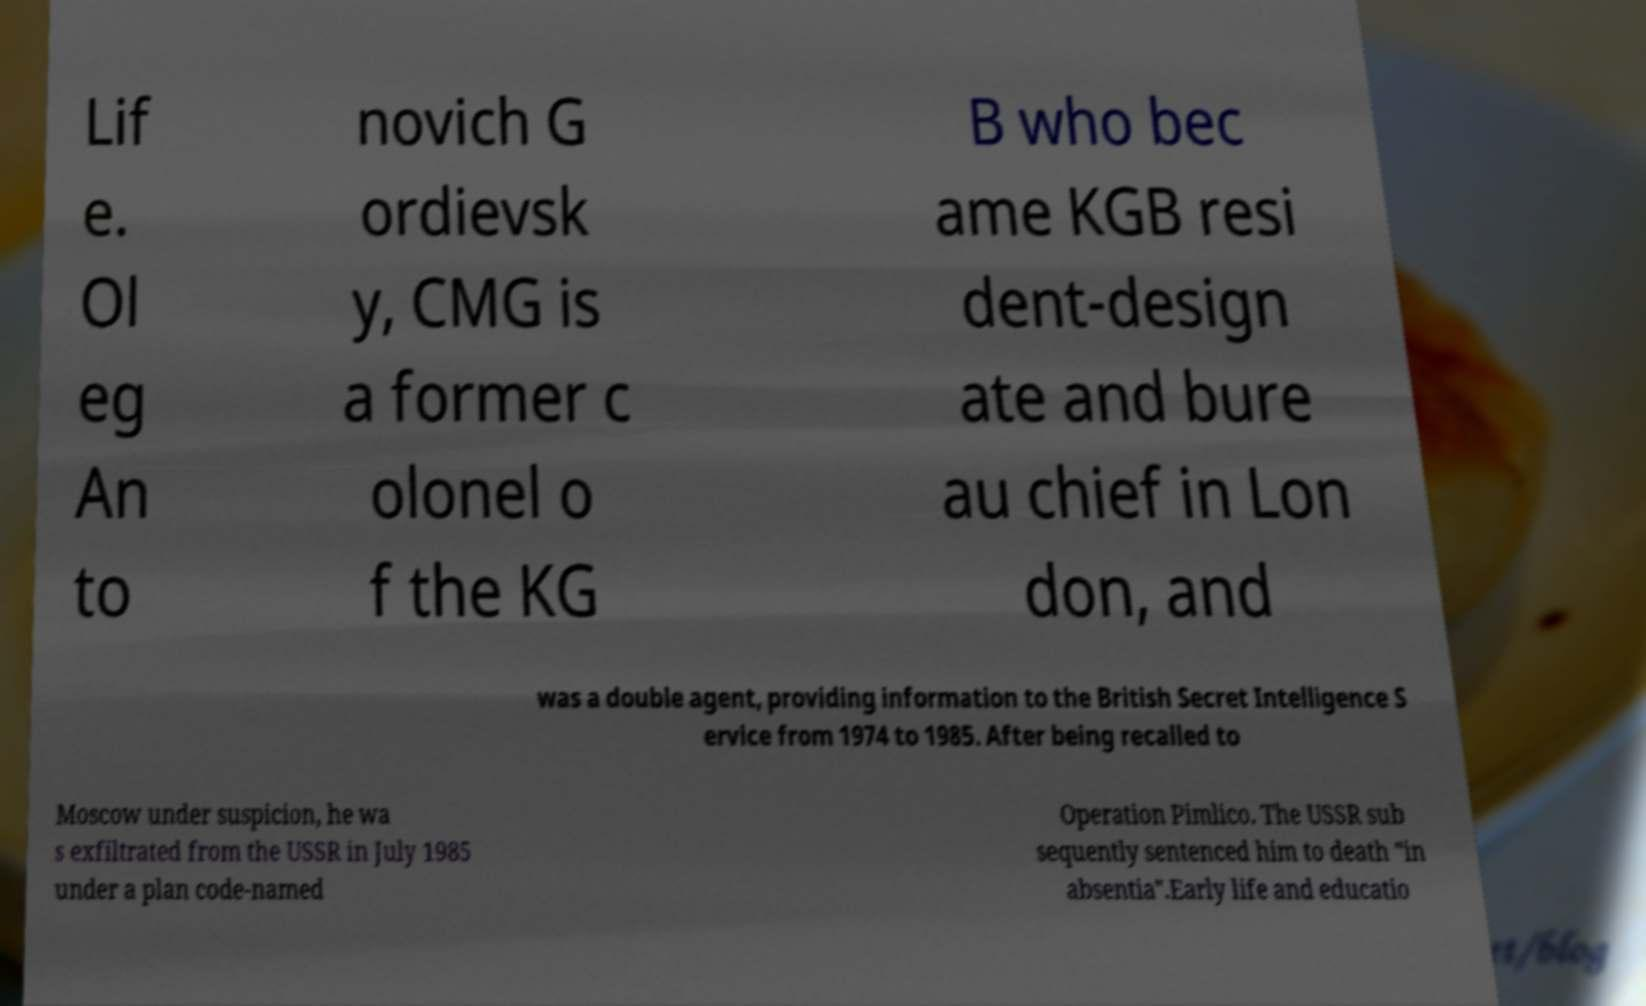Can you read and provide the text displayed in the image?This photo seems to have some interesting text. Can you extract and type it out for me? Lif e. Ol eg An to novich G ordievsk y, CMG is a former c olonel o f the KG B who bec ame KGB resi dent-design ate and bure au chief in Lon don, and was a double agent, providing information to the British Secret Intelligence S ervice from 1974 to 1985. After being recalled to Moscow under suspicion, he wa s exfiltrated from the USSR in July 1985 under a plan code-named Operation Pimlico. The USSR sub sequently sentenced him to death "in absentia".Early life and educatio 